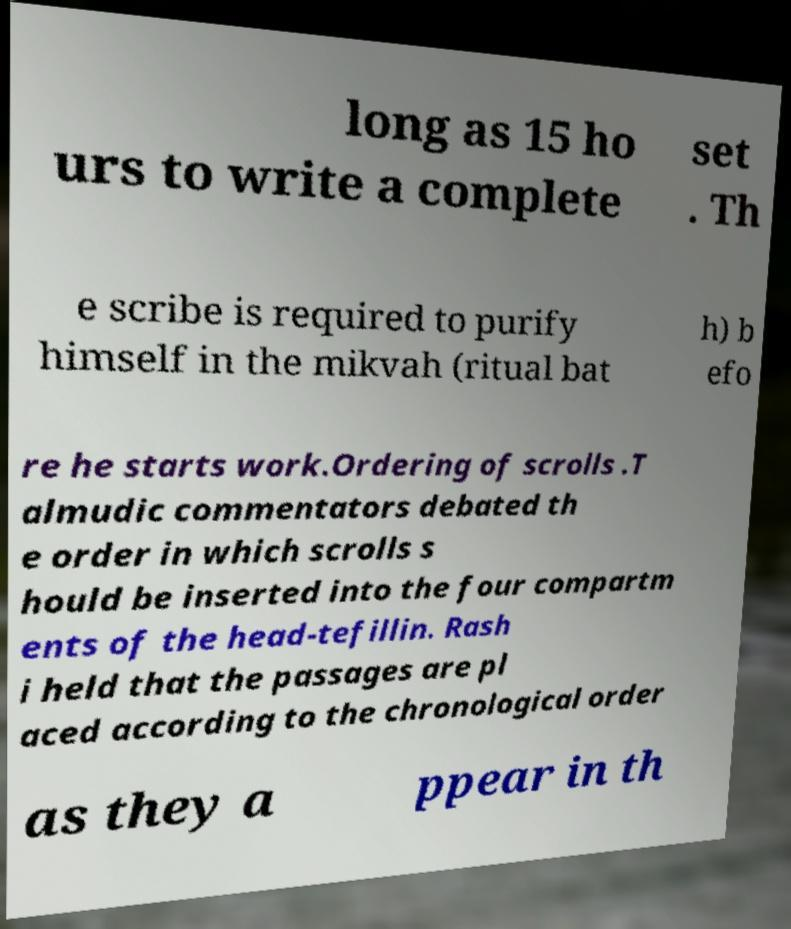Could you extract and type out the text from this image? long as 15 ho urs to write a complete set . Th e scribe is required to purify himself in the mikvah (ritual bat h) b efo re he starts work.Ordering of scrolls .T almudic commentators debated th e order in which scrolls s hould be inserted into the four compartm ents of the head-tefillin. Rash i held that the passages are pl aced according to the chronological order as they a ppear in th 